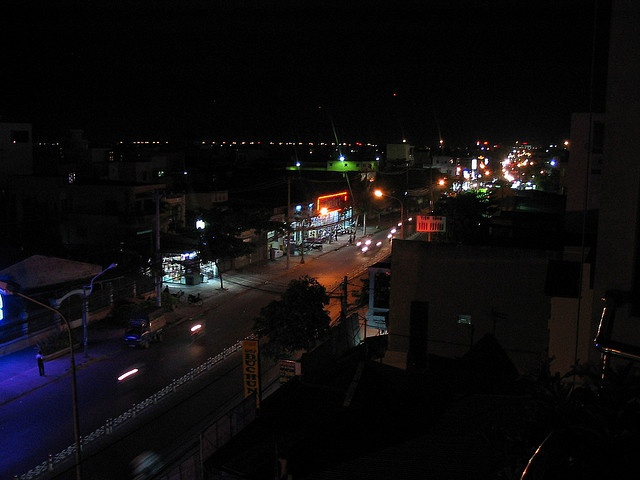Describe the objects in this image and their specific colors. I can see car in black, navy, and gray tones, car in black, brown, white, and maroon tones, motorcycle in black, maroon, and brown tones, people in black, navy, darkblue, and blue tones, and motorcycle in black tones in this image. 